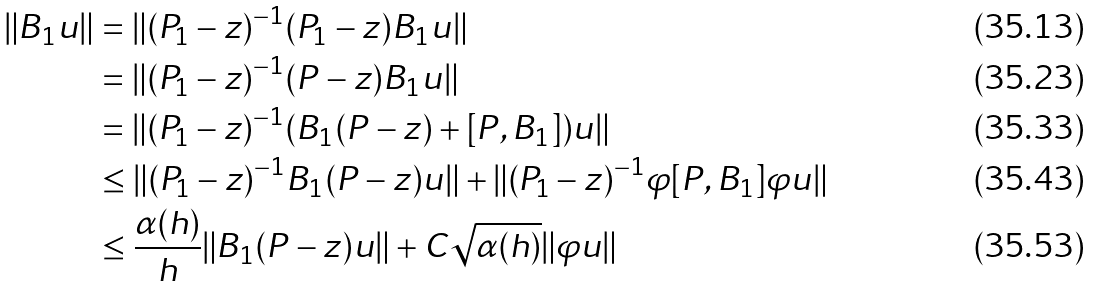<formula> <loc_0><loc_0><loc_500><loc_500>\| B _ { 1 } u \| & = \| ( P _ { 1 } - z ) ^ { - 1 } ( P _ { 1 } - z ) B _ { 1 } u \| \\ & = \| ( P _ { 1 } - z ) ^ { - 1 } ( P - z ) B _ { 1 } u \| \\ & = \| ( P _ { 1 } - z ) ^ { - 1 } ( B _ { 1 } ( P - z ) + [ P , B _ { 1 } ] ) u \| \\ & \leq \| ( P _ { 1 } - z ) ^ { - 1 } B _ { 1 } ( P - z ) u \| + \| ( P _ { 1 } - z ) ^ { - 1 } \varphi [ P , B _ { 1 } ] \varphi u \| \\ & \leq \frac { \alpha ( h ) } { h } \| B _ { 1 } ( P - z ) u \| + C \sqrt { \alpha ( h ) } \| \varphi u \|</formula> 